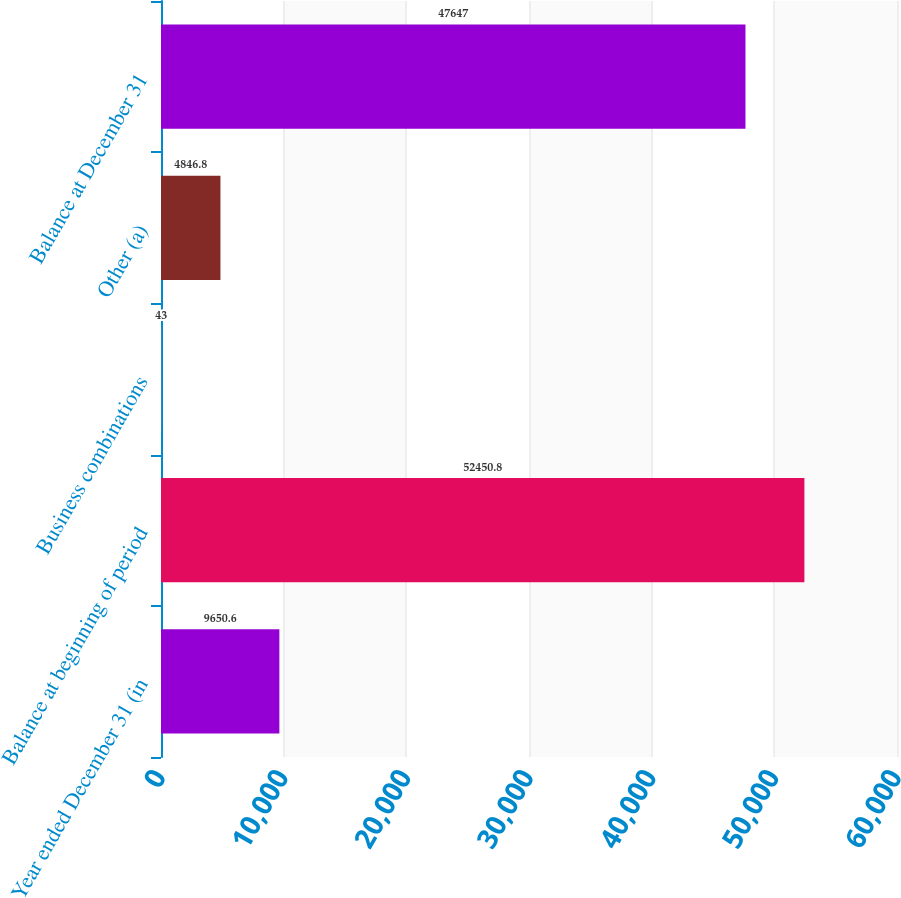Convert chart to OTSL. <chart><loc_0><loc_0><loc_500><loc_500><bar_chart><fcel>Year ended December 31 (in<fcel>Balance at beginning of period<fcel>Business combinations<fcel>Other (a)<fcel>Balance at December 31<nl><fcel>9650.6<fcel>52450.8<fcel>43<fcel>4846.8<fcel>47647<nl></chart> 